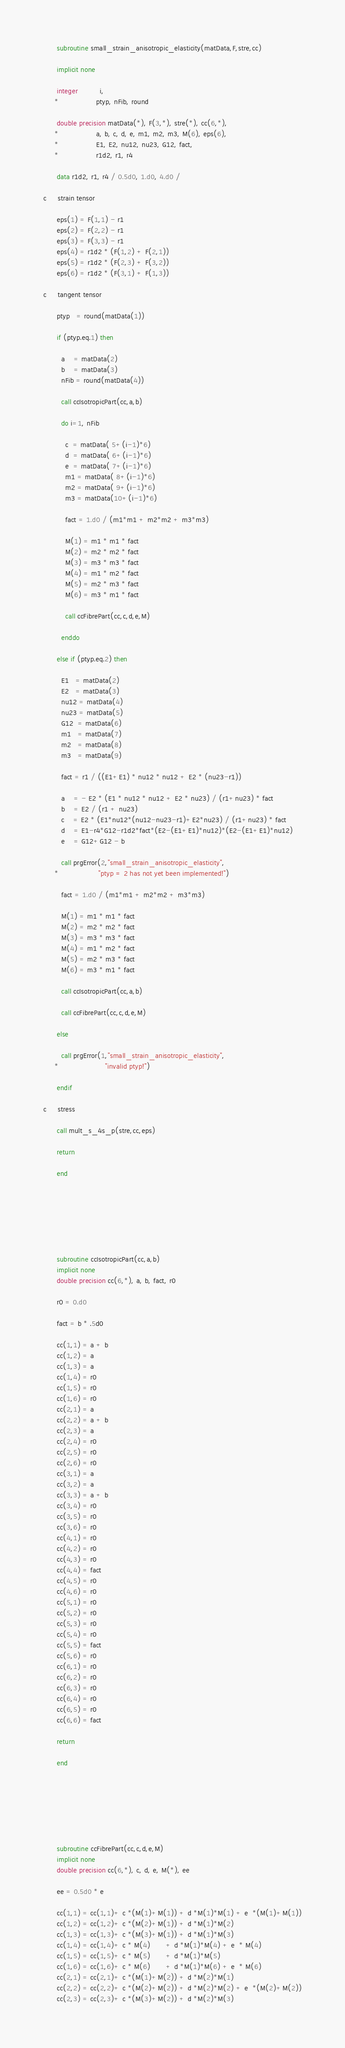<code> <loc_0><loc_0><loc_500><loc_500><_FORTRAN_>

      subroutine small_strain_anisotropic_elasticity(matData,F,stre,cc)

      implicit none

      integer          i,
     *                 ptyp, nFib, round

      double precision matData(*), F(3,*), stre(*), cc(6,*),
     *                 a, b, c, d, e, m1, m2, m3, M(6), eps(6), 
     *                 E1, E2, nu12, nu23, G12, fact, 
     *                 r1d2, r1, r4

      data r1d2, r1, r4 / 0.5d0, 1.d0, 4.d0 /

c     strain tensor

      eps(1) = F(1,1) - r1
      eps(2) = F(2,2) - r1
      eps(3) = F(3,3) - r1
      eps(4) = r1d2 * (F(1,2) + F(2,1))
      eps(5) = r1d2 * (F(2,3) + F(3,2))
      eps(6) = r1d2 * (F(3,1) + F(1,3))

c     tangent tensor

      ptyp   = round(matData(1))

      if (ptyp.eq.1) then

        a    = matData(2)
        b    = matData(3)
        nFib = round(matData(4))

        call ccIsotropicPart(cc,a,b)

        do i=1, nFib

          c  = matData( 5+(i-1)*6)
          d  = matData( 6+(i-1)*6)
          e  = matData( 7+(i-1)*6)
          m1 = matData( 8+(i-1)*6)
          m2 = matData( 9+(i-1)*6)
          m3 = matData(10+(i-1)*6)

          fact = 1.d0 / (m1*m1 + m2*m2 + m3*m3)

          M(1) = m1 * m1 * fact
          M(2) = m2 * m2 * fact
          M(3) = m3 * m3 * fact
          M(4) = m1 * m2 * fact
          M(5) = m2 * m3 * fact
          M(6) = m3 * m1 * fact

          call ccFibrePart(cc,c,d,e,M)

        enddo

      else if (ptyp.eq.2) then

        E1   = matData(2)
        E2   = matData(3)
        nu12 = matData(4)
        nu23 = matData(5)
        G12  = matData(6)
        m1   = matData(7)
        m2   = matData(8)
        m3   = matData(9)

        fact = r1 / ((E1+E1) * nu12 * nu12 + E2 * (nu23-r1))

        a    = - E2 * (E1 * nu12 * nu12 + E2 * nu23) / (r1+nu23) * fact
        b    = E2 / (r1 + nu23)
        c    = E2 * (E1*nu12*(nu12-nu23-r1)+E2*nu23) / (r1+nu23) * fact
        d    = E1-r4*G12-r1d2*fact*(E2-(E1+E1)*nu12)*(E2-(E1+E1)*nu12)
        e    = G12+G12 - b

        call prgError(2,"small_strain_anisotropic_elasticity",
     *                  "ptyp = 2 has not yet been implemented!")

        fact = 1.d0 / (m1*m1 + m2*m2 + m3*m3)

        M(1) = m1 * m1 * fact
        M(2) = m2 * m2 * fact
        M(3) = m3 * m3 * fact
        M(4) = m1 * m2 * fact
        M(5) = m2 * m3 * fact
        M(6) = m3 * m1 * fact

        call ccIsotropicPart(cc,a,b)

        call ccFibrePart(cc,c,d,e,M)

      else

        call prgError(1,"small_strain_anisotropic_elasticity",
     *                     "invalid ptyp!")

      endif

c     stress

      call mult_s_4s_p(stre,cc,eps)

      return

      end







      subroutine ccIsotropicPart(cc,a,b)
      implicit none
      double precision cc(6,*), a, b, fact, r0

      r0 = 0.d0

      fact = b * .5d0

      cc(1,1) = a + b
      cc(1,2) = a
      cc(1,3) = a
      cc(1,4) = r0
      cc(1,5) = r0
      cc(1,6) = r0
      cc(2,1) = a
      cc(2,2) = a + b
      cc(2,3) = a
      cc(2,4) = r0
      cc(2,5) = r0
      cc(2,6) = r0
      cc(3,1) = a
      cc(3,2) = a
      cc(3,3) = a + b
      cc(3,4) = r0
      cc(3,5) = r0
      cc(3,6) = r0
      cc(4,1) = r0
      cc(4,2) = r0
      cc(4,3) = r0
      cc(4,4) = fact
      cc(4,5) = r0
      cc(4,6) = r0
      cc(5,1) = r0
      cc(5,2) = r0
      cc(5,3) = r0
      cc(5,4) = r0
      cc(5,5) = fact
      cc(5,6) = r0
      cc(6,1) = r0
      cc(6,2) = r0
      cc(6,3) = r0
      cc(6,4) = r0
      cc(6,5) = r0
      cc(6,6) = fact

      return

      end







      subroutine ccFibrePart(cc,c,d,e,M)
      implicit none
      double precision cc(6,*), c, d, e, M(*), ee

      ee = 0.5d0 * e

      cc(1,1) = cc(1,1)+ c *(M(1)+M(1)) + d *M(1)*M(1) + e  *(M(1)+M(1))
      cc(1,2) = cc(1,2)+ c *(M(2)+M(1)) + d *M(1)*M(2)
      cc(1,3) = cc(1,3)+ c *(M(3)+M(1)) + d *M(1)*M(3)
      cc(1,4) = cc(1,4)+ c * M(4)       + d *M(1)*M(4) + e  * M(4)
      cc(1,5) = cc(1,5)+ c * M(5)       + d *M(1)*M(5)
      cc(1,6) = cc(1,6)+ c * M(6)       + d *M(1)*M(6) + e  * M(6)
      cc(2,1) = cc(2,1)+ c *(M(1)+M(2)) + d *M(2)*M(1)
      cc(2,2) = cc(2,2)+ c *(M(2)+M(2)) + d *M(2)*M(2) + e  *(M(2)+M(2))
      cc(2,3) = cc(2,3)+ c *(M(3)+M(2)) + d *M(2)*M(3)</code> 